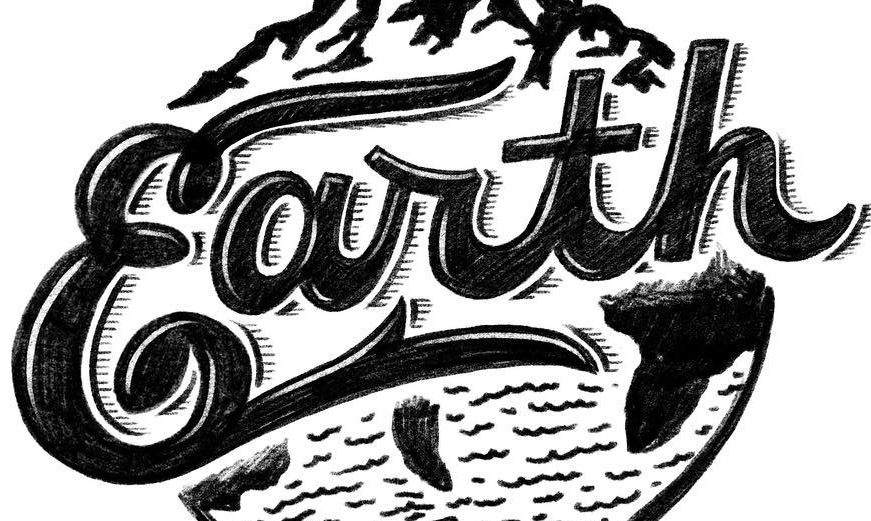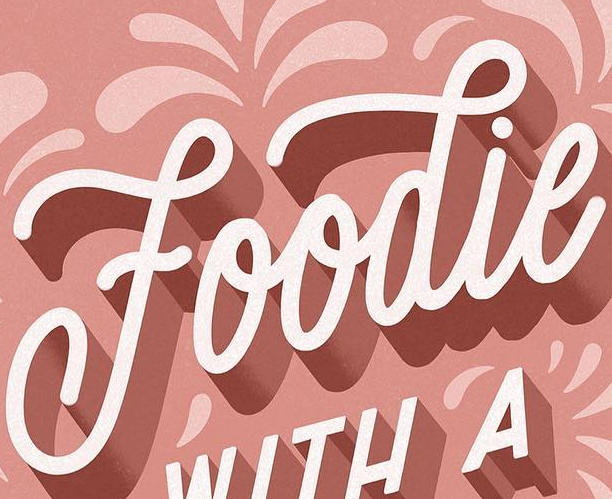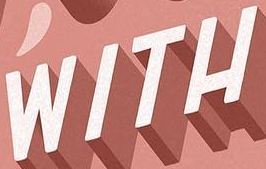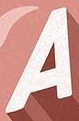Read the text from these images in sequence, separated by a semicolon. Earth; Foodie; WITH; A 